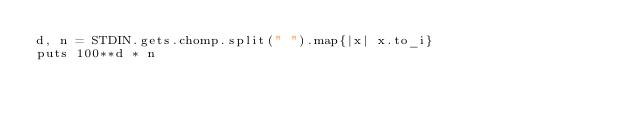<code> <loc_0><loc_0><loc_500><loc_500><_Ruby_>d, n = STDIN.gets.chomp.split(" ").map{|x| x.to_i}
puts 100**d * n</code> 